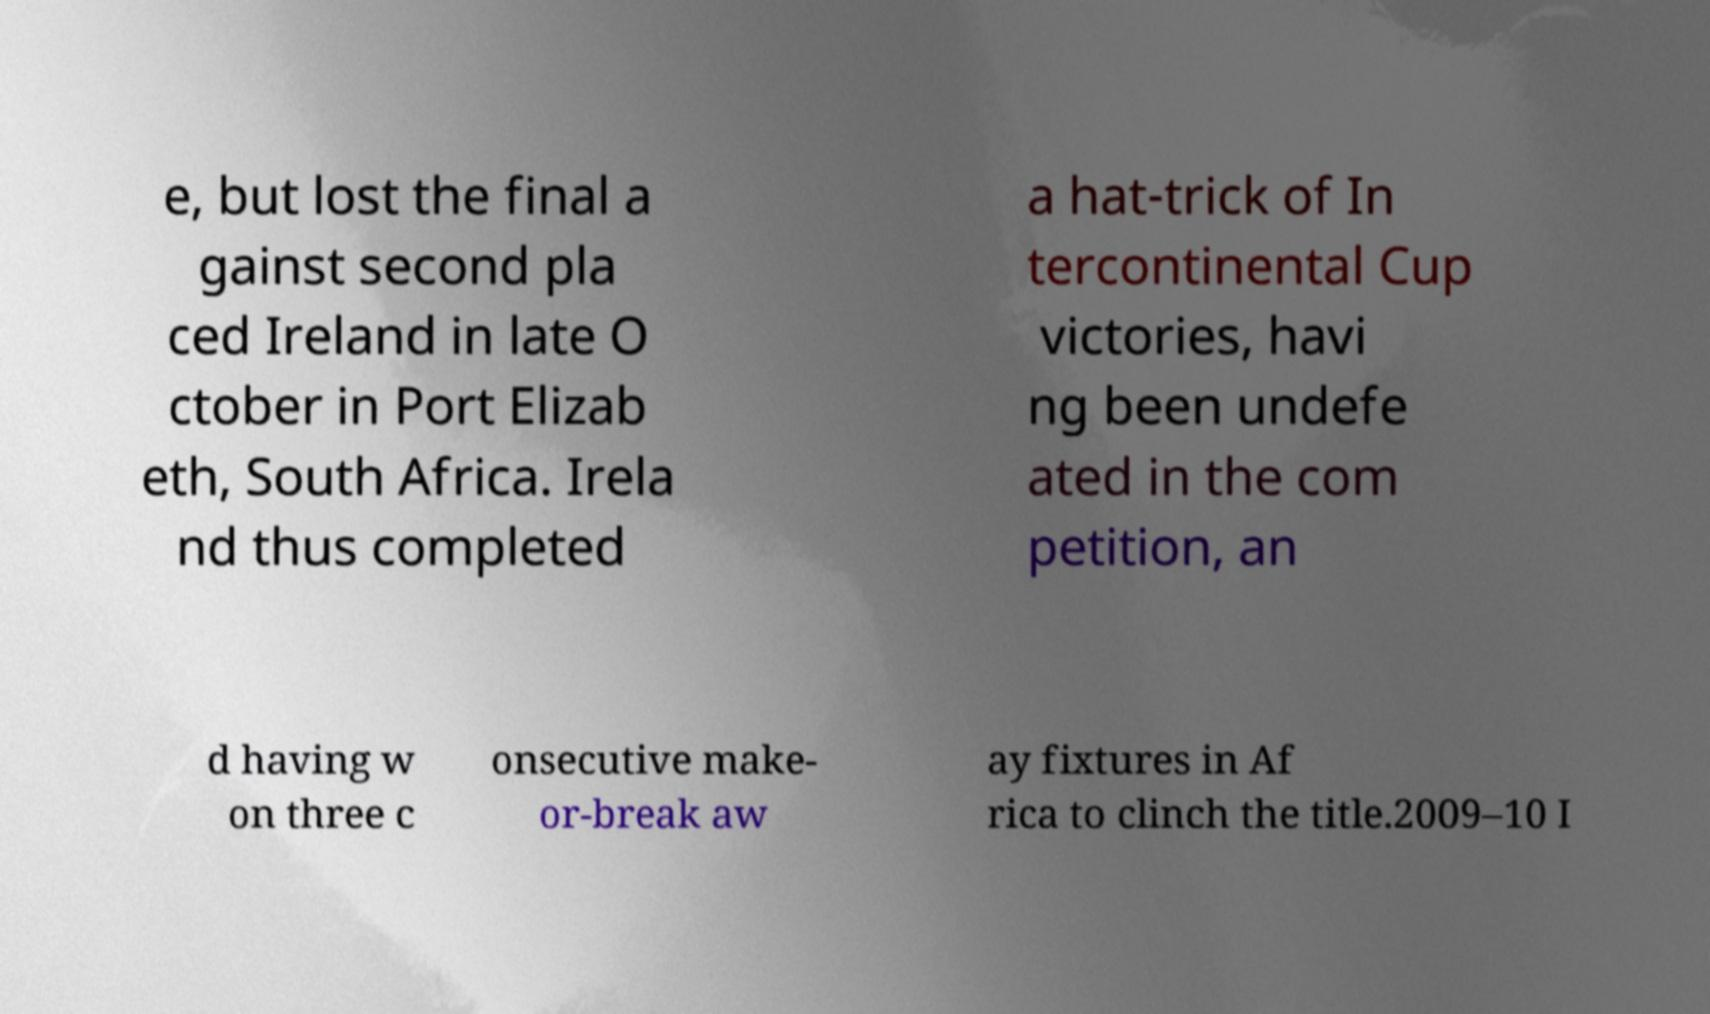There's text embedded in this image that I need extracted. Can you transcribe it verbatim? e, but lost the final a gainst second pla ced Ireland in late O ctober in Port Elizab eth, South Africa. Irela nd thus completed a hat-trick of In tercontinental Cup victories, havi ng been undefe ated in the com petition, an d having w on three c onsecutive make- or-break aw ay fixtures in Af rica to clinch the title.2009–10 I 